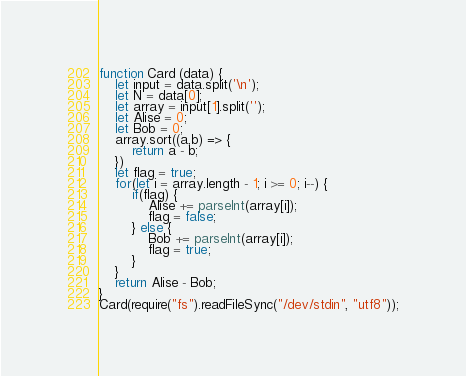<code> <loc_0><loc_0><loc_500><loc_500><_JavaScript_>function Card (data) {
	let input = data.split('\n');
	let N = data[0];
	let array = input[1].split('');
	let Alise = 0;
	let Bob = 0;
	array.sort((a,b) => {
		return a - b;
	})
	let flag = true;
	for(let i = array.length - 1; i >= 0; i--) {
		if(flag) {
			Alise += parseInt(array[i]);
			flag = false;
		} else {
			Bob += parseInt(array[i]);
			flag = true;
		}
	}
	return Alise - Bob;
}
Card(require("fs").readFileSync("/dev/stdin", "utf8"));</code> 